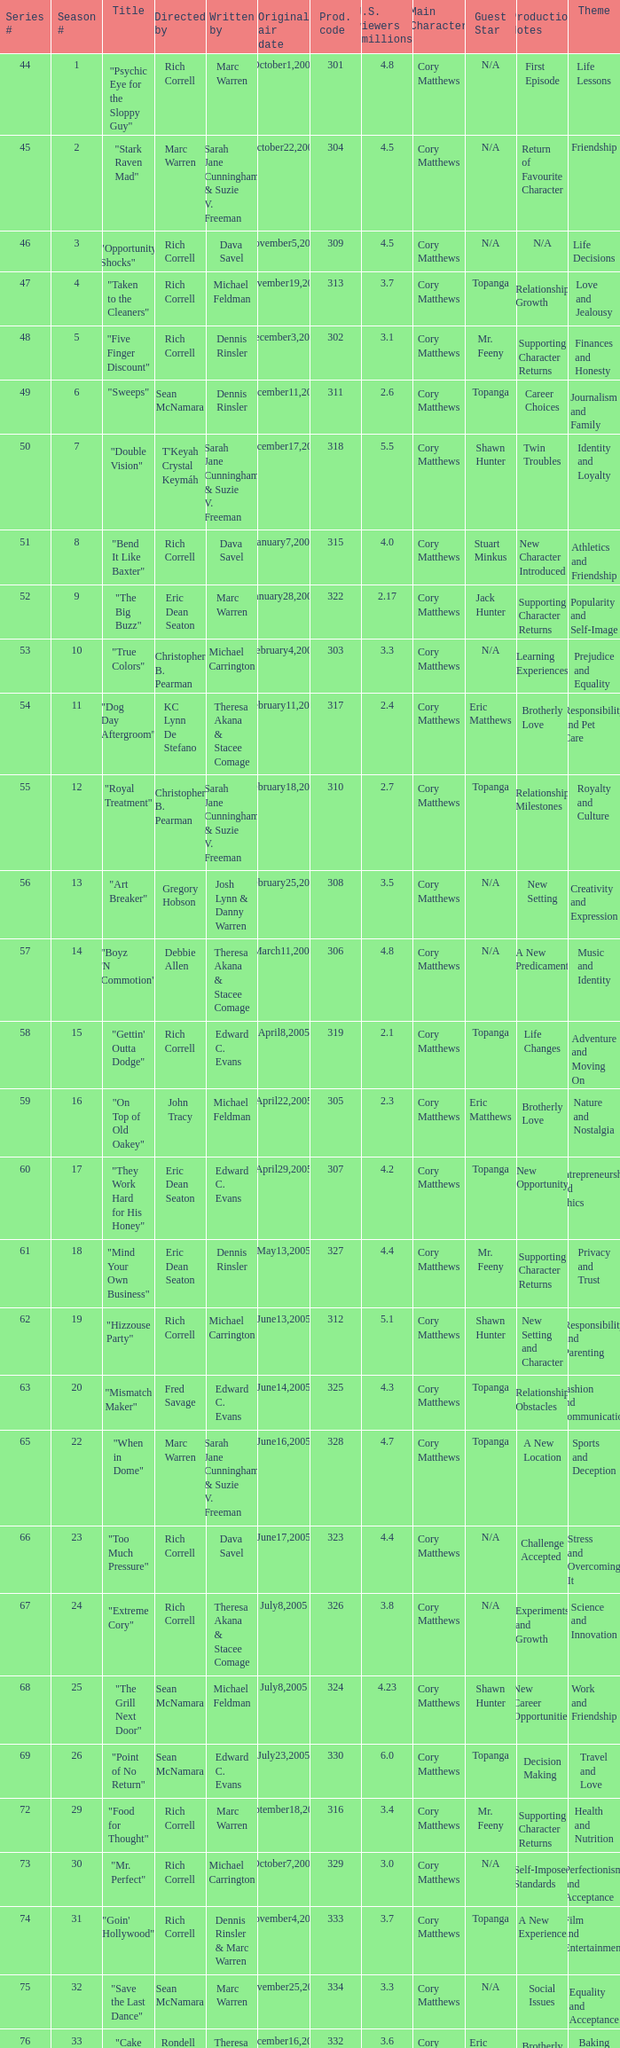What is the title of the episode directed by Rich Correll and written by Dennis Rinsler? "Five Finger Discount". 